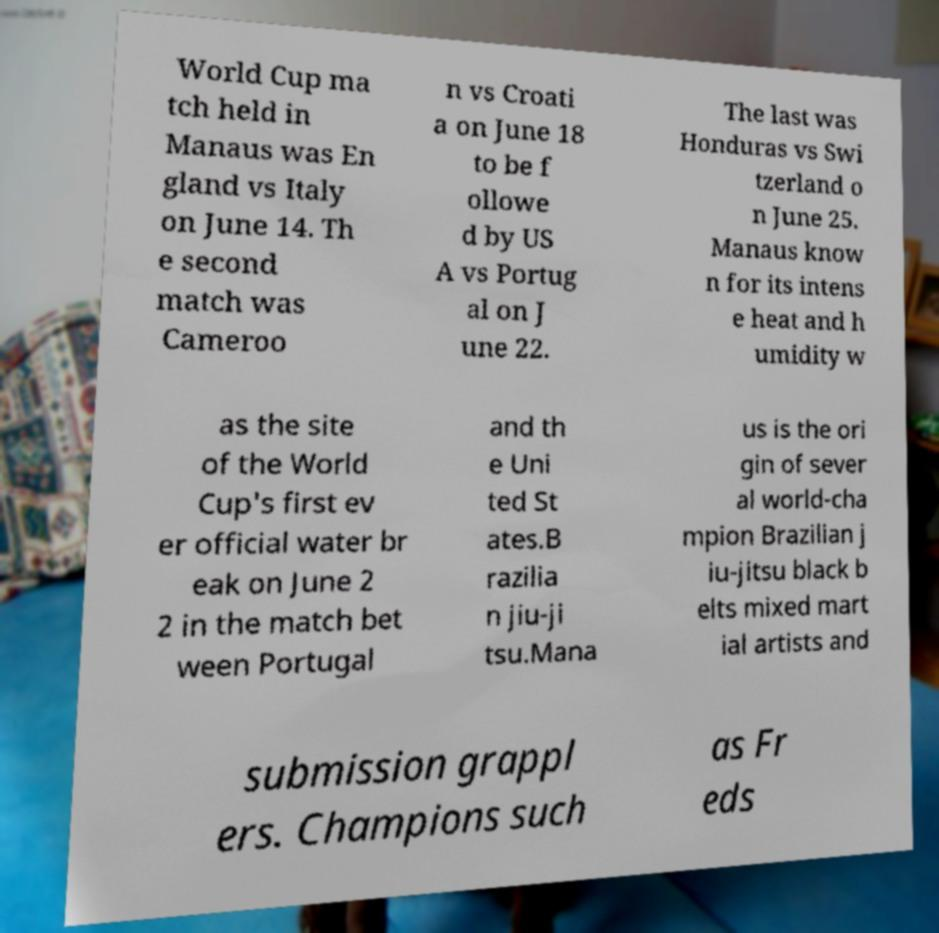Please read and relay the text visible in this image. What does it say? World Cup ma tch held in Manaus was En gland vs Italy on June 14. Th e second match was Cameroo n vs Croati a on June 18 to be f ollowe d by US A vs Portug al on J une 22. The last was Honduras vs Swi tzerland o n June 25. Manaus know n for its intens e heat and h umidity w as the site of the World Cup's first ev er official water br eak on June 2 2 in the match bet ween Portugal and th e Uni ted St ates.B razilia n jiu-ji tsu.Mana us is the ori gin of sever al world-cha mpion Brazilian j iu-jitsu black b elts mixed mart ial artists and submission grappl ers. Champions such as Fr eds 